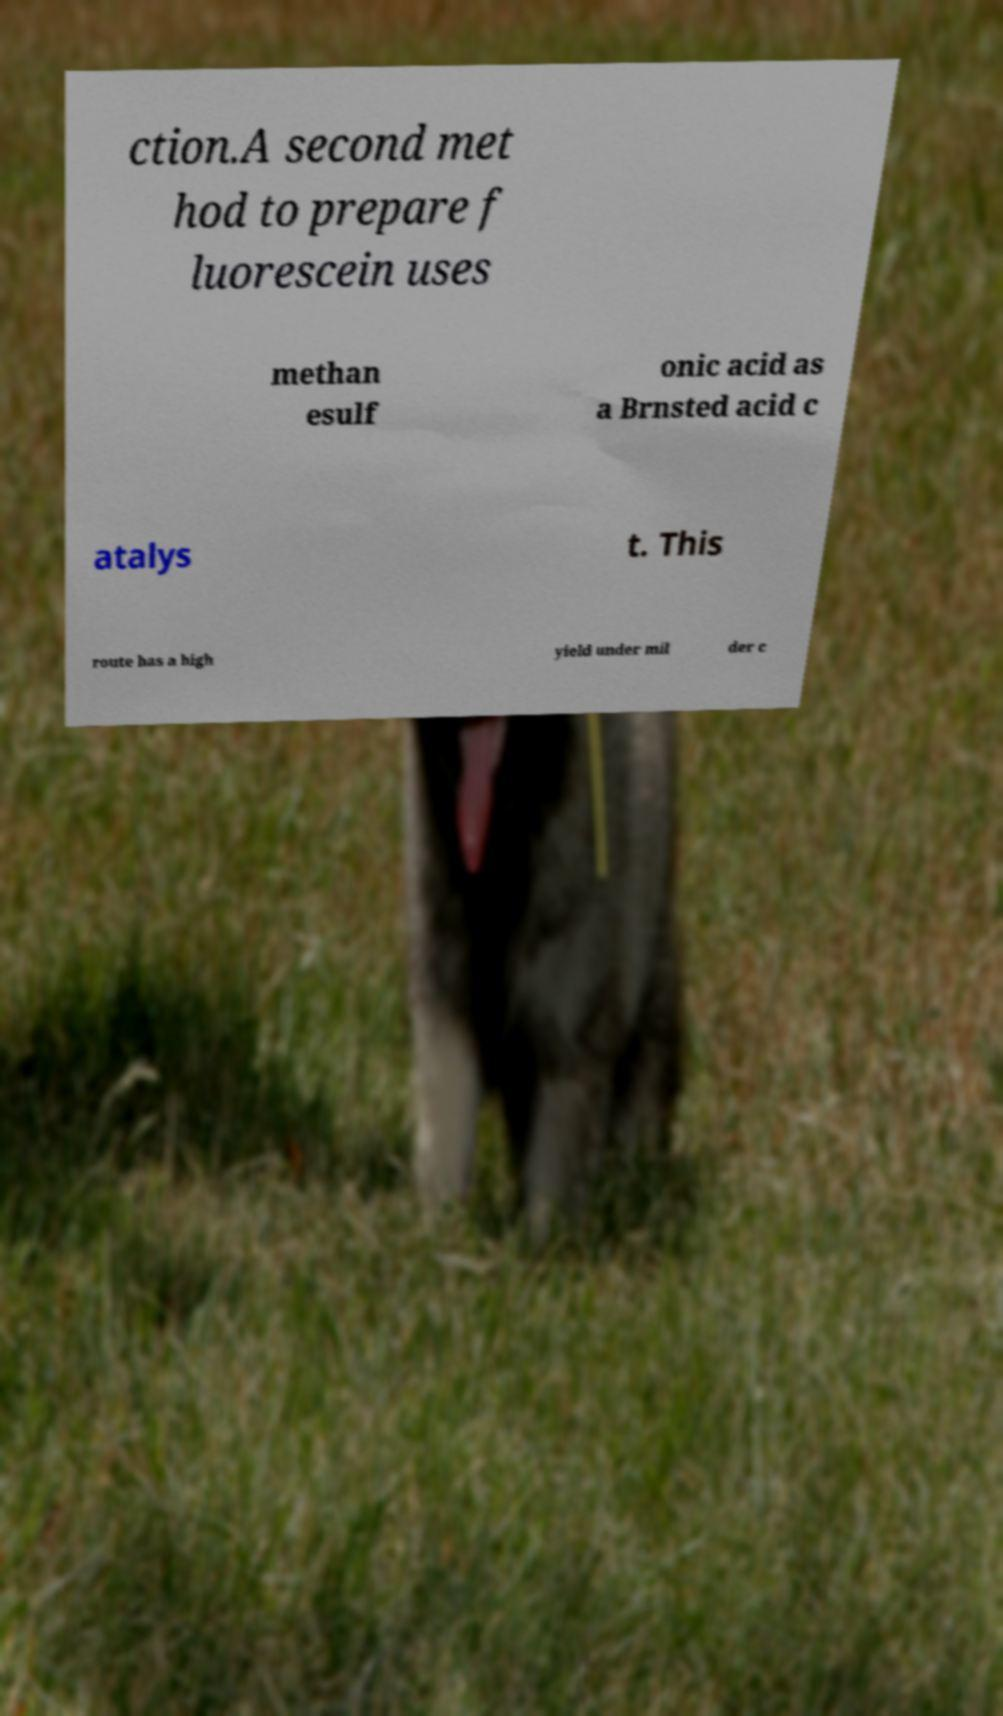There's text embedded in this image that I need extracted. Can you transcribe it verbatim? ction.A second met hod to prepare f luorescein uses methan esulf onic acid as a Brnsted acid c atalys t. This route has a high yield under mil der c 